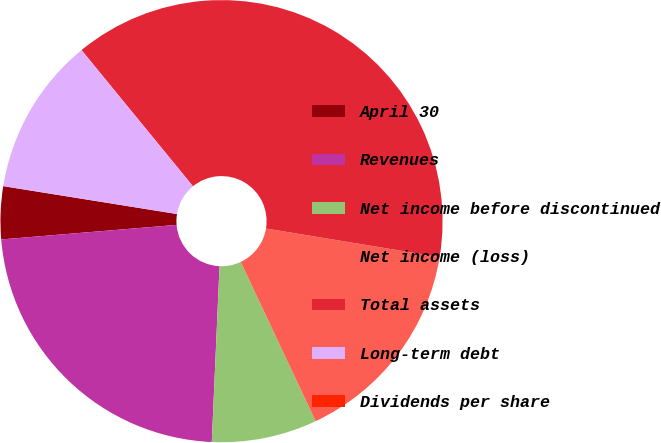<chart> <loc_0><loc_0><loc_500><loc_500><pie_chart><fcel>April 30<fcel>Revenues<fcel>Net income before discontinued<fcel>Net income (loss)<fcel>Total assets<fcel>Long-term debt<fcel>Dividends per share<nl><fcel>3.85%<fcel>22.98%<fcel>7.7%<fcel>15.4%<fcel>38.51%<fcel>11.55%<fcel>0.0%<nl></chart> 